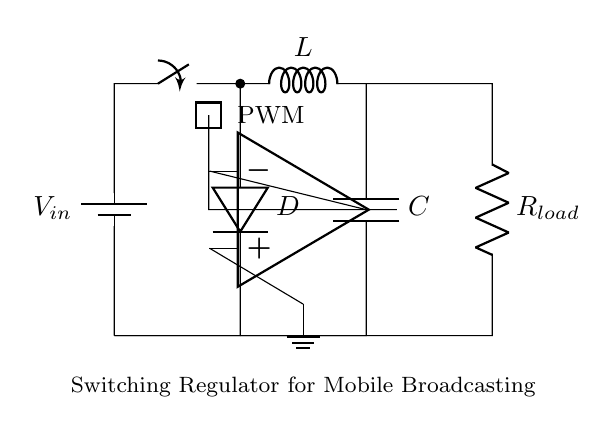What is the type of regulator shown in this circuit? The circuit is a switching regulator, as indicated by the presence of components such as the PWM block, inductor, and diode, which are characteristic of this type of power management system.
Answer: Switching regulator What component is used to store energy in this circuit? The inductor is specifically used for storing energy, as it is shown in the circuit and plays a crucial role in switching regulator operation by smoothing the current flow.
Answer: Inductor What is the purpose of the diode in the circuit? The diode allows current to flow in one direction, preventing reverse current that could damage other components. It is essential in controlling the flow of energy during the switching process.
Answer: Prevents reverse current What function does the PWM block serve in this design? The PWM block modulates the duty cycle of the signal, effectively controlling the voltage output by varying the time the switch is on or off, which optimizes efficiency in power delivery.
Answer: Voltage control What is connected to the output of the operational amplifier? The output of the operational amplifier connects to the PWM block, indicating it is likely used for feedback to control the switching process effectively based on load conditions.
Answer: PWM block What is the load resistance value indicated in the circuit? The load resistance value is represented by the symbol R load which is specified as such, but the precise numerical value is not given in the diagram.
Answer: R load How does the inductor help improve efficiency in this circuit? The inductor helps improve efficiency by storing energy during the switching cycle and releasing it when needed, minimizing energy loss and ensuring a smoother power output to the load.
Answer: Energy storage 